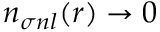Convert formula to latex. <formula><loc_0><loc_0><loc_500><loc_500>n _ { \sigma n l } ( r ) \to 0</formula> 